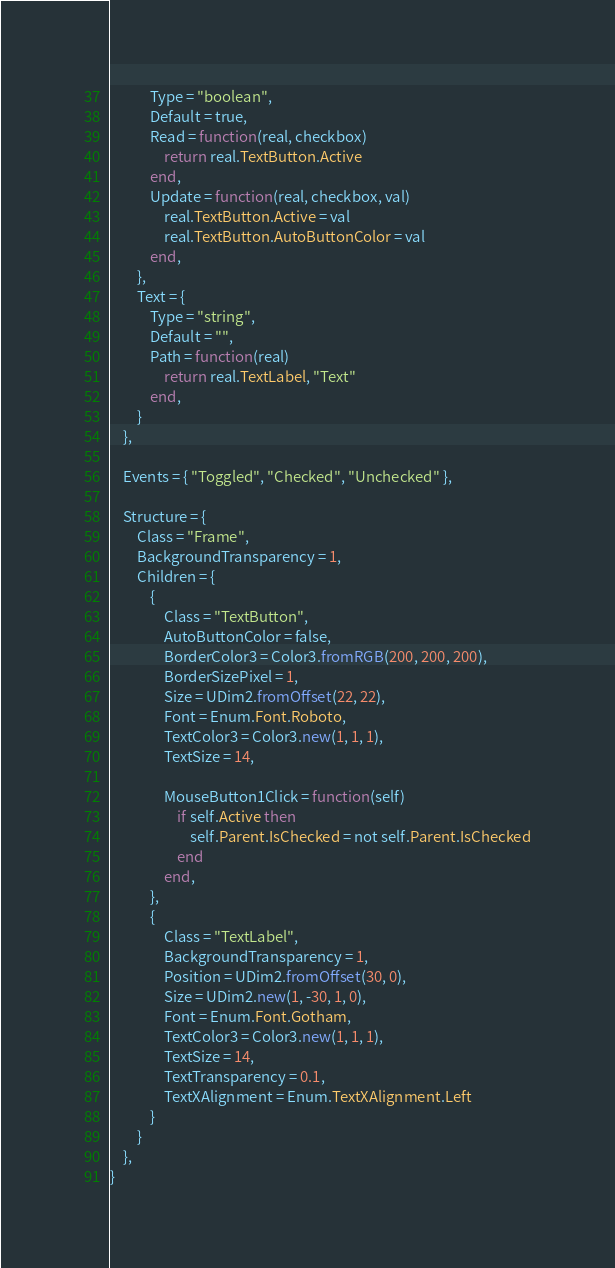<code> <loc_0><loc_0><loc_500><loc_500><_Lua_>			Type = "boolean",
			Default = true,
			Read = function(real, checkbox)
				return real.TextButton.Active
			end,
			Update = function(real, checkbox, val)
				real.TextButton.Active = val
				real.TextButton.AutoButtonColor = val
			end,
		},
		Text = {
			Type = "string",
			Default = "",
			Path = function(real)
				return real.TextLabel, "Text"
			end,
		}
	},

	Events = { "Toggled", "Checked", "Unchecked" },

	Structure = {
		Class = "Frame",
		BackgroundTransparency = 1,
		Children = {
			{
				Class = "TextButton",
				AutoButtonColor = false,
				BorderColor3 = Color3.fromRGB(200, 200, 200),
				BorderSizePixel = 1,
				Size = UDim2.fromOffset(22, 22),
				Font = Enum.Font.Roboto,
				TextColor3 = Color3.new(1, 1, 1),
				TextSize = 14,

				MouseButton1Click = function(self)
					if self.Active then
						self.Parent.IsChecked = not self.Parent.IsChecked
					end
				end,
			},
			{
				Class = "TextLabel",
				BackgroundTransparency = 1,
				Position = UDim2.fromOffset(30, 0),
				Size = UDim2.new(1, -30, 1, 0),
				Font = Enum.Font.Gotham,
				TextColor3 = Color3.new(1, 1, 1),
				TextSize = 14,
				TextTransparency = 0.1,
				TextXAlignment = Enum.TextXAlignment.Left
			}
		}
	},
}
</code> 